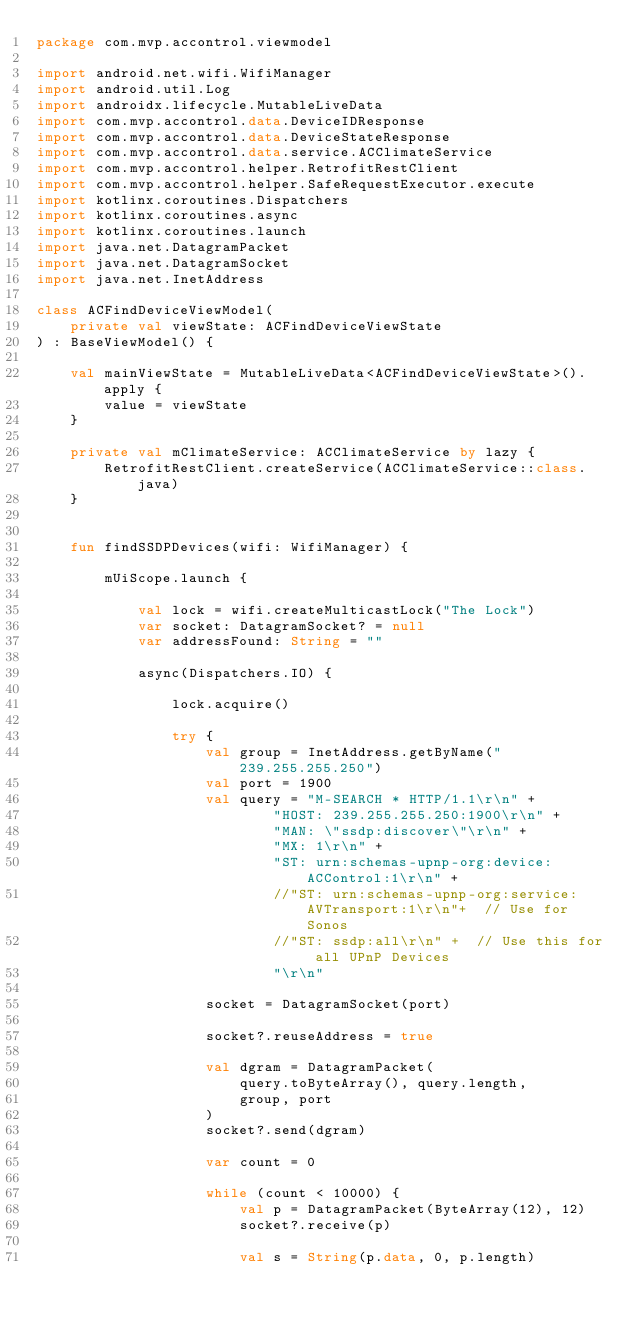<code> <loc_0><loc_0><loc_500><loc_500><_Kotlin_>package com.mvp.accontrol.viewmodel

import android.net.wifi.WifiManager
import android.util.Log
import androidx.lifecycle.MutableLiveData
import com.mvp.accontrol.data.DeviceIDResponse
import com.mvp.accontrol.data.DeviceStateResponse
import com.mvp.accontrol.data.service.ACClimateService
import com.mvp.accontrol.helper.RetrofitRestClient
import com.mvp.accontrol.helper.SafeRequestExecutor.execute
import kotlinx.coroutines.Dispatchers
import kotlinx.coroutines.async
import kotlinx.coroutines.launch
import java.net.DatagramPacket
import java.net.DatagramSocket
import java.net.InetAddress

class ACFindDeviceViewModel(
    private val viewState: ACFindDeviceViewState
) : BaseViewModel() {

    val mainViewState = MutableLiveData<ACFindDeviceViewState>().apply {
        value = viewState
    }

    private val mClimateService: ACClimateService by lazy {
        RetrofitRestClient.createService(ACClimateService::class.java)
    }


    fun findSSDPDevices(wifi: WifiManager) {

        mUiScope.launch {

            val lock = wifi.createMulticastLock("The Lock")
            var socket: DatagramSocket? = null
            var addressFound: String = ""

            async(Dispatchers.IO) {

                lock.acquire()

                try {
                    val group = InetAddress.getByName("239.255.255.250")
                    val port = 1900
                    val query = "M-SEARCH * HTTP/1.1\r\n" +
                            "HOST: 239.255.255.250:1900\r\n" +
                            "MAN: \"ssdp:discover\"\r\n" +
                            "MX: 1\r\n" +
                            "ST: urn:schemas-upnp-org:device:ACControl:1\r\n" +
                            //"ST: urn:schemas-upnp-org:service:AVTransport:1\r\n"+  // Use for Sonos
                            //"ST: ssdp:all\r\n" +  // Use this for all UPnP Devices
                            "\r\n"

                    socket = DatagramSocket(port)

                    socket?.reuseAddress = true

                    val dgram = DatagramPacket(
                        query.toByteArray(), query.length,
                        group, port
                    )
                    socket?.send(dgram)

                    var count = 0

                    while (count < 10000) {
                        val p = DatagramPacket(ByteArray(12), 12)
                        socket?.receive(p)

                        val s = String(p.data, 0, p.length)</code> 